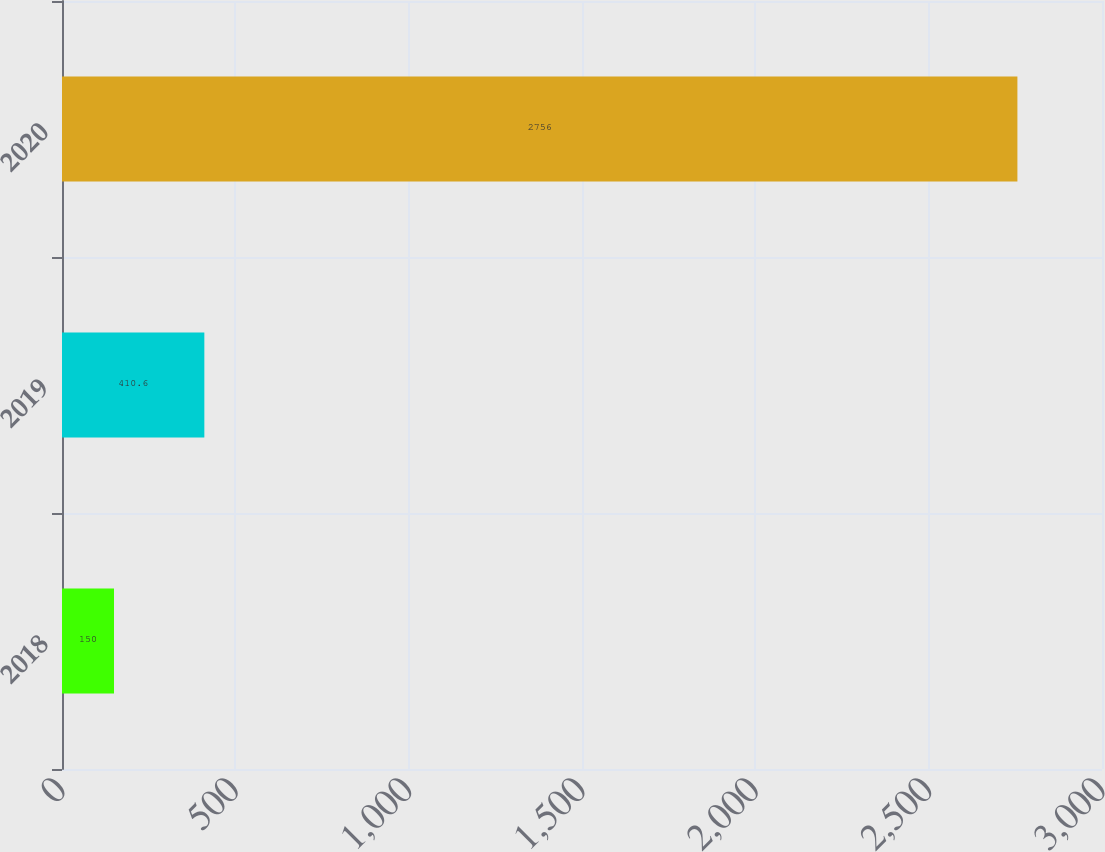Convert chart. <chart><loc_0><loc_0><loc_500><loc_500><bar_chart><fcel>2018<fcel>2019<fcel>2020<nl><fcel>150<fcel>410.6<fcel>2756<nl></chart> 